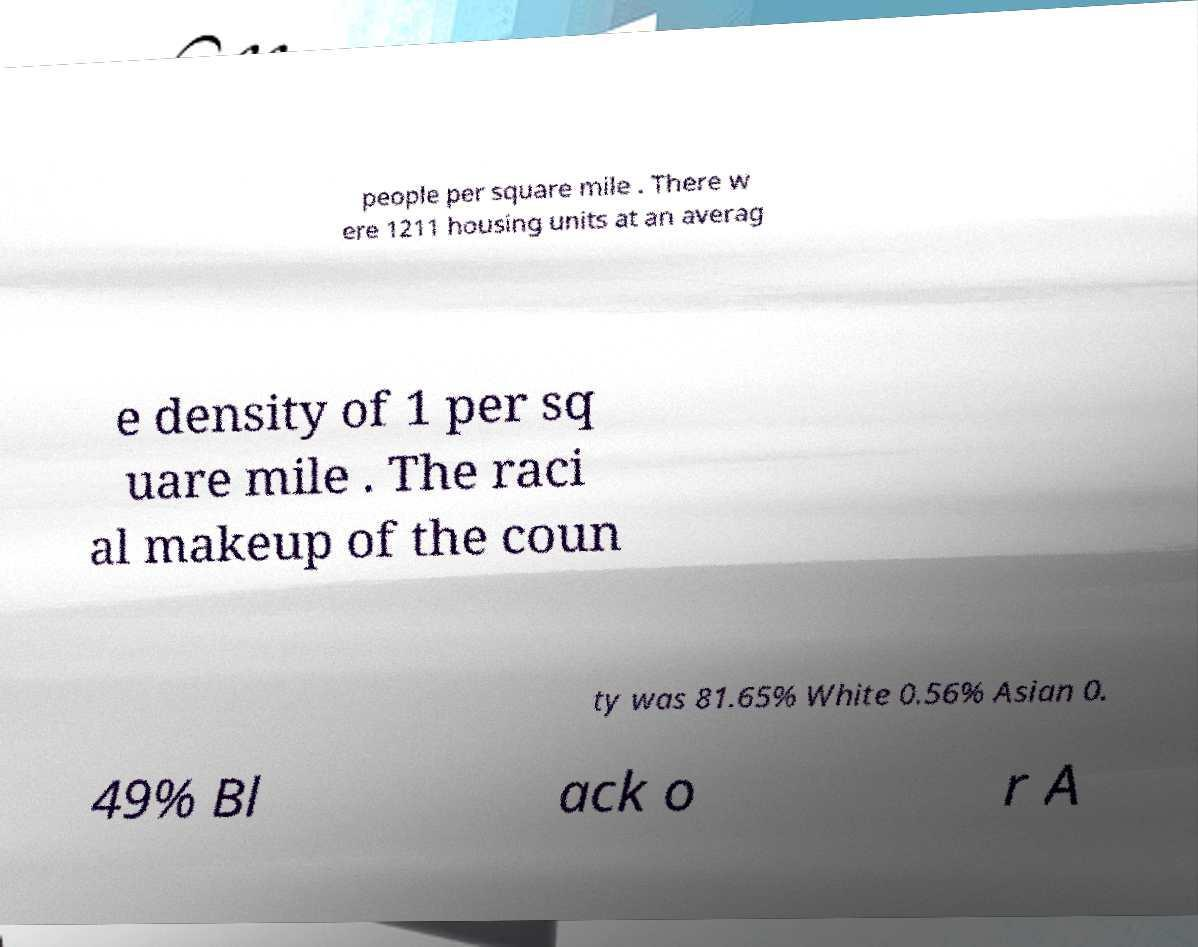Can you accurately transcribe the text from the provided image for me? people per square mile . There w ere 1211 housing units at an averag e density of 1 per sq uare mile . The raci al makeup of the coun ty was 81.65% White 0.56% Asian 0. 49% Bl ack o r A 